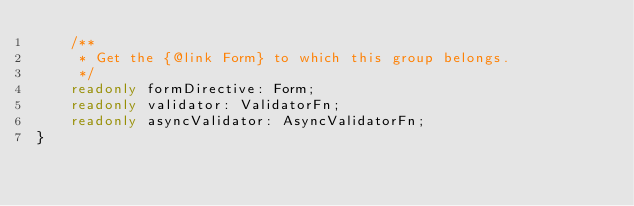Convert code to text. <code><loc_0><loc_0><loc_500><loc_500><_TypeScript_>    /**
     * Get the {@link Form} to which this group belongs.
     */
    readonly formDirective: Form;
    readonly validator: ValidatorFn;
    readonly asyncValidator: AsyncValidatorFn;
}
</code> 